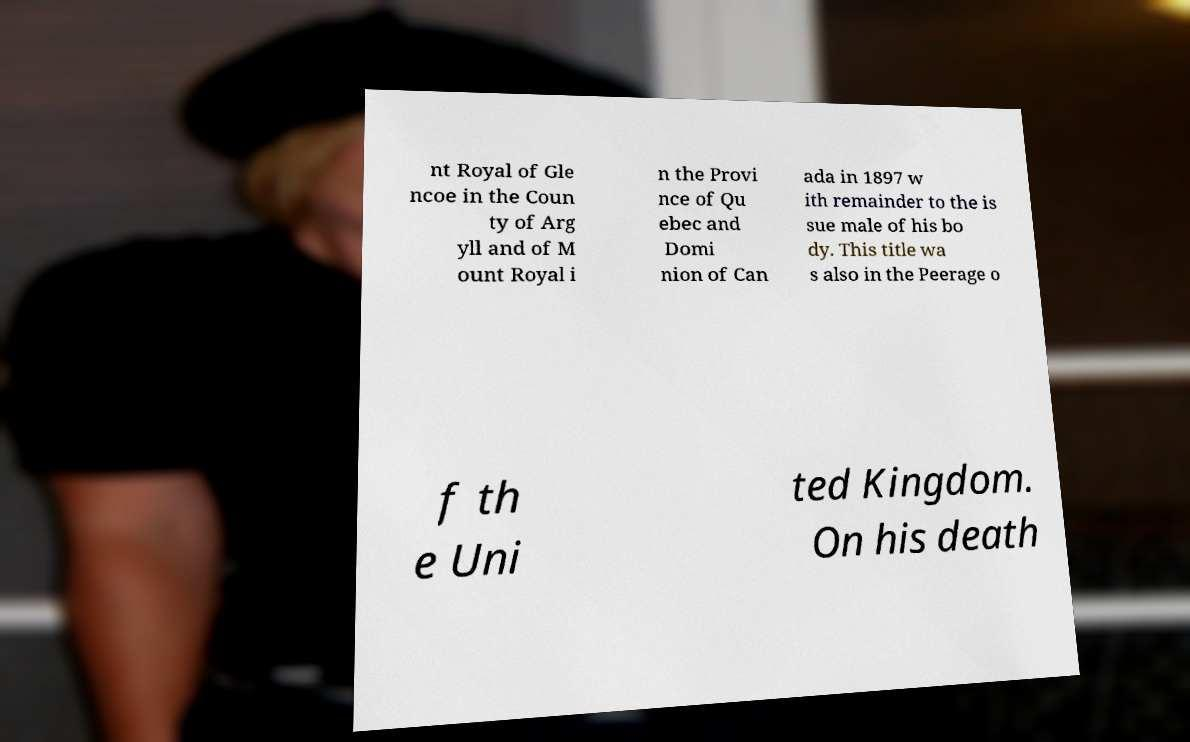What messages or text are displayed in this image? I need them in a readable, typed format. nt Royal of Gle ncoe in the Coun ty of Arg yll and of M ount Royal i n the Provi nce of Qu ebec and Domi nion of Can ada in 1897 w ith remainder to the is sue male of his bo dy. This title wa s also in the Peerage o f th e Uni ted Kingdom. On his death 